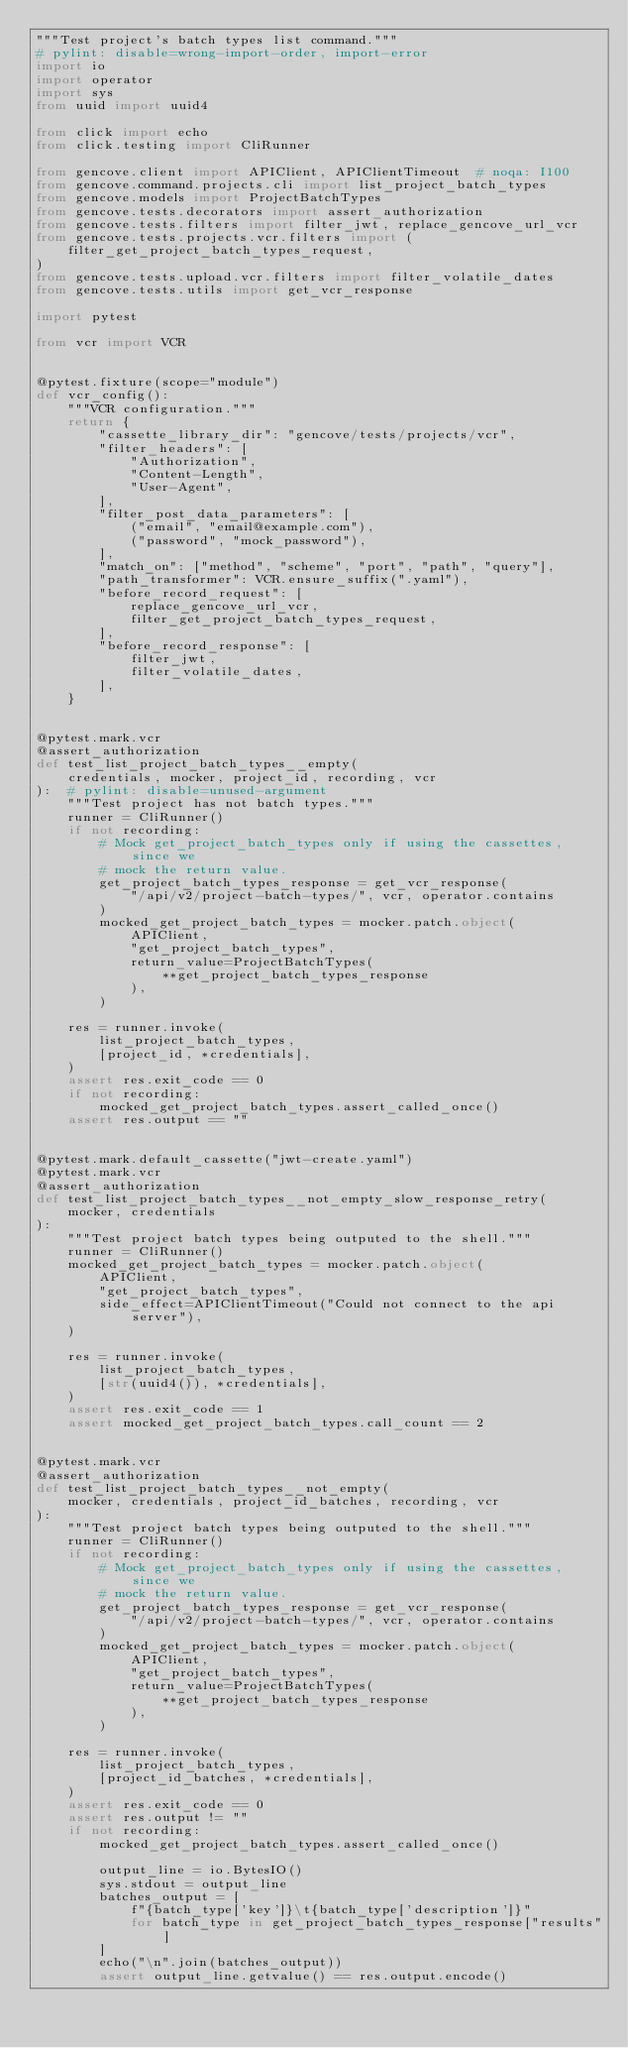Convert code to text. <code><loc_0><loc_0><loc_500><loc_500><_Python_>"""Test project's batch types list command."""
# pylint: disable=wrong-import-order, import-error
import io
import operator
import sys
from uuid import uuid4

from click import echo
from click.testing import CliRunner

from gencove.client import APIClient, APIClientTimeout  # noqa: I100
from gencove.command.projects.cli import list_project_batch_types
from gencove.models import ProjectBatchTypes
from gencove.tests.decorators import assert_authorization
from gencove.tests.filters import filter_jwt, replace_gencove_url_vcr
from gencove.tests.projects.vcr.filters import (
    filter_get_project_batch_types_request,
)
from gencove.tests.upload.vcr.filters import filter_volatile_dates
from gencove.tests.utils import get_vcr_response

import pytest

from vcr import VCR


@pytest.fixture(scope="module")
def vcr_config():
    """VCR configuration."""
    return {
        "cassette_library_dir": "gencove/tests/projects/vcr",
        "filter_headers": [
            "Authorization",
            "Content-Length",
            "User-Agent",
        ],
        "filter_post_data_parameters": [
            ("email", "email@example.com"),
            ("password", "mock_password"),
        ],
        "match_on": ["method", "scheme", "port", "path", "query"],
        "path_transformer": VCR.ensure_suffix(".yaml"),
        "before_record_request": [
            replace_gencove_url_vcr,
            filter_get_project_batch_types_request,
        ],
        "before_record_response": [
            filter_jwt,
            filter_volatile_dates,
        ],
    }


@pytest.mark.vcr
@assert_authorization
def test_list_project_batch_types__empty(
    credentials, mocker, project_id, recording, vcr
):  # pylint: disable=unused-argument
    """Test project has not batch types."""
    runner = CliRunner()
    if not recording:
        # Mock get_project_batch_types only if using the cassettes, since we
        # mock the return value.
        get_project_batch_types_response = get_vcr_response(
            "/api/v2/project-batch-types/", vcr, operator.contains
        )
        mocked_get_project_batch_types = mocker.patch.object(
            APIClient,
            "get_project_batch_types",
            return_value=ProjectBatchTypes(
                **get_project_batch_types_response
            ),
        )

    res = runner.invoke(
        list_project_batch_types,
        [project_id, *credentials],
    )
    assert res.exit_code == 0
    if not recording:
        mocked_get_project_batch_types.assert_called_once()
    assert res.output == ""


@pytest.mark.default_cassette("jwt-create.yaml")
@pytest.mark.vcr
@assert_authorization
def test_list_project_batch_types__not_empty_slow_response_retry(
    mocker, credentials
):
    """Test project batch types being outputed to the shell."""
    runner = CliRunner()
    mocked_get_project_batch_types = mocker.patch.object(
        APIClient,
        "get_project_batch_types",
        side_effect=APIClientTimeout("Could not connect to the api server"),
    )

    res = runner.invoke(
        list_project_batch_types,
        [str(uuid4()), *credentials],
    )
    assert res.exit_code == 1
    assert mocked_get_project_batch_types.call_count == 2


@pytest.mark.vcr
@assert_authorization
def test_list_project_batch_types__not_empty(
    mocker, credentials, project_id_batches, recording, vcr
):
    """Test project batch types being outputed to the shell."""
    runner = CliRunner()
    if not recording:
        # Mock get_project_batch_types only if using the cassettes, since we
        # mock the return value.
        get_project_batch_types_response = get_vcr_response(
            "/api/v2/project-batch-types/", vcr, operator.contains
        )
        mocked_get_project_batch_types = mocker.patch.object(
            APIClient,
            "get_project_batch_types",
            return_value=ProjectBatchTypes(
                **get_project_batch_types_response
            ),
        )

    res = runner.invoke(
        list_project_batch_types,
        [project_id_batches, *credentials],
    )
    assert res.exit_code == 0
    assert res.output != ""
    if not recording:
        mocked_get_project_batch_types.assert_called_once()

        output_line = io.BytesIO()
        sys.stdout = output_line
        batches_output = [
            f"{batch_type['key']}\t{batch_type['description']}"
            for batch_type in get_project_batch_types_response["results"]
        ]
        echo("\n".join(batches_output))
        assert output_line.getvalue() == res.output.encode()
</code> 